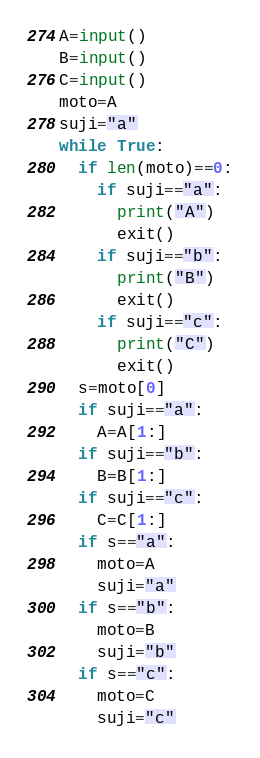<code> <loc_0><loc_0><loc_500><loc_500><_Python_>A=input()
B=input()
C=input()
moto=A
suji="a"
while True:
  if len(moto)==0:
    if suji=="a":
      print("A")
      exit()
    if suji=="b":
      print("B")
      exit()
    if suji=="c":
      print("C")
      exit()
  s=moto[0]
  if suji=="a":
    A=A[1:]
  if suji=="b":
    B=B[1:]
  if suji=="c":
    C=C[1:]
  if s=="a":
    moto=A
    suji="a"
  if s=="b":
    moto=B
    suji="b"
  if s=="c":
    moto=C
    suji="c"</code> 